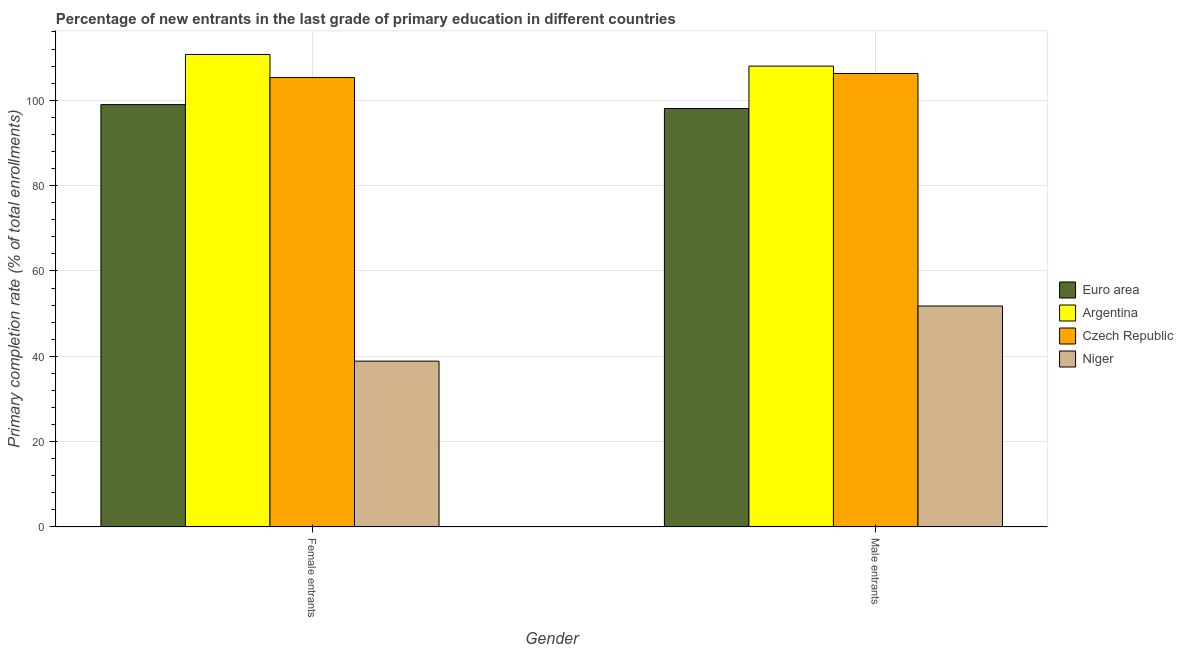How many different coloured bars are there?
Your response must be concise. 4. How many groups of bars are there?
Make the answer very short. 2. Are the number of bars per tick equal to the number of legend labels?
Your response must be concise. Yes. Are the number of bars on each tick of the X-axis equal?
Your answer should be compact. Yes. How many bars are there on the 2nd tick from the left?
Your response must be concise. 4. What is the label of the 2nd group of bars from the left?
Your answer should be compact. Male entrants. What is the primary completion rate of male entrants in Argentina?
Keep it short and to the point. 107.99. Across all countries, what is the maximum primary completion rate of female entrants?
Offer a very short reply. 110.73. Across all countries, what is the minimum primary completion rate of female entrants?
Offer a very short reply. 38.86. In which country was the primary completion rate of male entrants maximum?
Provide a succinct answer. Argentina. In which country was the primary completion rate of male entrants minimum?
Give a very brief answer. Niger. What is the total primary completion rate of male entrants in the graph?
Provide a succinct answer. 364.1. What is the difference between the primary completion rate of male entrants in Argentina and that in Czech Republic?
Offer a terse response. 1.73. What is the difference between the primary completion rate of male entrants in Czech Republic and the primary completion rate of female entrants in Euro area?
Give a very brief answer. 7.29. What is the average primary completion rate of female entrants per country?
Offer a very short reply. 88.47. What is the difference between the primary completion rate of female entrants and primary completion rate of male entrants in Czech Republic?
Make the answer very short. -0.95. In how many countries, is the primary completion rate of female entrants greater than 76 %?
Offer a very short reply. 3. What is the ratio of the primary completion rate of male entrants in Czech Republic to that in Euro area?
Give a very brief answer. 1.08. Is the primary completion rate of male entrants in Euro area less than that in Argentina?
Offer a very short reply. Yes. What does the 2nd bar from the left in Male entrants represents?
Offer a terse response. Argentina. What does the 2nd bar from the right in Female entrants represents?
Your answer should be compact. Czech Republic. How many bars are there?
Give a very brief answer. 8. Are all the bars in the graph horizontal?
Offer a terse response. No. How many countries are there in the graph?
Offer a terse response. 4. What is the difference between two consecutive major ticks on the Y-axis?
Provide a succinct answer. 20. Does the graph contain any zero values?
Your response must be concise. No. Where does the legend appear in the graph?
Provide a succinct answer. Center right. How are the legend labels stacked?
Offer a very short reply. Vertical. What is the title of the graph?
Make the answer very short. Percentage of new entrants in the last grade of primary education in different countries. Does "Middle income" appear as one of the legend labels in the graph?
Provide a short and direct response. No. What is the label or title of the Y-axis?
Ensure brevity in your answer.  Primary completion rate (% of total enrollments). What is the Primary completion rate (% of total enrollments) in Euro area in Female entrants?
Your response must be concise. 98.97. What is the Primary completion rate (% of total enrollments) in Argentina in Female entrants?
Offer a terse response. 110.73. What is the Primary completion rate (% of total enrollments) of Czech Republic in Female entrants?
Offer a terse response. 105.32. What is the Primary completion rate (% of total enrollments) of Niger in Female entrants?
Offer a very short reply. 38.86. What is the Primary completion rate (% of total enrollments) of Euro area in Male entrants?
Keep it short and to the point. 98.06. What is the Primary completion rate (% of total enrollments) in Argentina in Male entrants?
Your response must be concise. 107.99. What is the Primary completion rate (% of total enrollments) of Czech Republic in Male entrants?
Your response must be concise. 106.26. What is the Primary completion rate (% of total enrollments) in Niger in Male entrants?
Your answer should be compact. 51.78. Across all Gender, what is the maximum Primary completion rate (% of total enrollments) of Euro area?
Make the answer very short. 98.97. Across all Gender, what is the maximum Primary completion rate (% of total enrollments) of Argentina?
Ensure brevity in your answer.  110.73. Across all Gender, what is the maximum Primary completion rate (% of total enrollments) in Czech Republic?
Keep it short and to the point. 106.26. Across all Gender, what is the maximum Primary completion rate (% of total enrollments) in Niger?
Provide a short and direct response. 51.78. Across all Gender, what is the minimum Primary completion rate (% of total enrollments) in Euro area?
Your answer should be very brief. 98.06. Across all Gender, what is the minimum Primary completion rate (% of total enrollments) in Argentina?
Provide a short and direct response. 107.99. Across all Gender, what is the minimum Primary completion rate (% of total enrollments) of Czech Republic?
Ensure brevity in your answer.  105.32. Across all Gender, what is the minimum Primary completion rate (% of total enrollments) in Niger?
Keep it short and to the point. 38.86. What is the total Primary completion rate (% of total enrollments) of Euro area in the graph?
Offer a terse response. 197.04. What is the total Primary completion rate (% of total enrollments) in Argentina in the graph?
Ensure brevity in your answer.  218.72. What is the total Primary completion rate (% of total enrollments) in Czech Republic in the graph?
Your response must be concise. 211.58. What is the total Primary completion rate (% of total enrollments) of Niger in the graph?
Your answer should be compact. 90.64. What is the difference between the Primary completion rate (% of total enrollments) in Euro area in Female entrants and that in Male entrants?
Offer a very short reply. 0.91. What is the difference between the Primary completion rate (% of total enrollments) of Argentina in Female entrants and that in Male entrants?
Your answer should be very brief. 2.73. What is the difference between the Primary completion rate (% of total enrollments) of Czech Republic in Female entrants and that in Male entrants?
Your answer should be very brief. -0.95. What is the difference between the Primary completion rate (% of total enrollments) of Niger in Female entrants and that in Male entrants?
Keep it short and to the point. -12.92. What is the difference between the Primary completion rate (% of total enrollments) in Euro area in Female entrants and the Primary completion rate (% of total enrollments) in Argentina in Male entrants?
Your response must be concise. -9.02. What is the difference between the Primary completion rate (% of total enrollments) in Euro area in Female entrants and the Primary completion rate (% of total enrollments) in Czech Republic in Male entrants?
Provide a succinct answer. -7.29. What is the difference between the Primary completion rate (% of total enrollments) in Euro area in Female entrants and the Primary completion rate (% of total enrollments) in Niger in Male entrants?
Offer a terse response. 47.2. What is the difference between the Primary completion rate (% of total enrollments) in Argentina in Female entrants and the Primary completion rate (% of total enrollments) in Czech Republic in Male entrants?
Ensure brevity in your answer.  4.47. What is the difference between the Primary completion rate (% of total enrollments) of Argentina in Female entrants and the Primary completion rate (% of total enrollments) of Niger in Male entrants?
Your answer should be very brief. 58.95. What is the difference between the Primary completion rate (% of total enrollments) of Czech Republic in Female entrants and the Primary completion rate (% of total enrollments) of Niger in Male entrants?
Ensure brevity in your answer.  53.54. What is the average Primary completion rate (% of total enrollments) in Euro area per Gender?
Offer a very short reply. 98.52. What is the average Primary completion rate (% of total enrollments) of Argentina per Gender?
Keep it short and to the point. 109.36. What is the average Primary completion rate (% of total enrollments) in Czech Republic per Gender?
Offer a terse response. 105.79. What is the average Primary completion rate (% of total enrollments) of Niger per Gender?
Offer a terse response. 45.32. What is the difference between the Primary completion rate (% of total enrollments) in Euro area and Primary completion rate (% of total enrollments) in Argentina in Female entrants?
Keep it short and to the point. -11.75. What is the difference between the Primary completion rate (% of total enrollments) of Euro area and Primary completion rate (% of total enrollments) of Czech Republic in Female entrants?
Ensure brevity in your answer.  -6.34. What is the difference between the Primary completion rate (% of total enrollments) in Euro area and Primary completion rate (% of total enrollments) in Niger in Female entrants?
Ensure brevity in your answer.  60.11. What is the difference between the Primary completion rate (% of total enrollments) in Argentina and Primary completion rate (% of total enrollments) in Czech Republic in Female entrants?
Make the answer very short. 5.41. What is the difference between the Primary completion rate (% of total enrollments) in Argentina and Primary completion rate (% of total enrollments) in Niger in Female entrants?
Offer a very short reply. 71.87. What is the difference between the Primary completion rate (% of total enrollments) of Czech Republic and Primary completion rate (% of total enrollments) of Niger in Female entrants?
Offer a very short reply. 66.45. What is the difference between the Primary completion rate (% of total enrollments) of Euro area and Primary completion rate (% of total enrollments) of Argentina in Male entrants?
Make the answer very short. -9.93. What is the difference between the Primary completion rate (% of total enrollments) in Euro area and Primary completion rate (% of total enrollments) in Czech Republic in Male entrants?
Your response must be concise. -8.2. What is the difference between the Primary completion rate (% of total enrollments) of Euro area and Primary completion rate (% of total enrollments) of Niger in Male entrants?
Provide a succinct answer. 46.28. What is the difference between the Primary completion rate (% of total enrollments) in Argentina and Primary completion rate (% of total enrollments) in Czech Republic in Male entrants?
Offer a very short reply. 1.73. What is the difference between the Primary completion rate (% of total enrollments) of Argentina and Primary completion rate (% of total enrollments) of Niger in Male entrants?
Make the answer very short. 56.22. What is the difference between the Primary completion rate (% of total enrollments) in Czech Republic and Primary completion rate (% of total enrollments) in Niger in Male entrants?
Your answer should be very brief. 54.48. What is the ratio of the Primary completion rate (% of total enrollments) of Euro area in Female entrants to that in Male entrants?
Your answer should be compact. 1.01. What is the ratio of the Primary completion rate (% of total enrollments) of Argentina in Female entrants to that in Male entrants?
Offer a very short reply. 1.03. What is the ratio of the Primary completion rate (% of total enrollments) of Niger in Female entrants to that in Male entrants?
Provide a short and direct response. 0.75. What is the difference between the highest and the second highest Primary completion rate (% of total enrollments) of Euro area?
Your response must be concise. 0.91. What is the difference between the highest and the second highest Primary completion rate (% of total enrollments) in Argentina?
Give a very brief answer. 2.73. What is the difference between the highest and the second highest Primary completion rate (% of total enrollments) in Czech Republic?
Keep it short and to the point. 0.95. What is the difference between the highest and the second highest Primary completion rate (% of total enrollments) of Niger?
Offer a terse response. 12.92. What is the difference between the highest and the lowest Primary completion rate (% of total enrollments) in Euro area?
Make the answer very short. 0.91. What is the difference between the highest and the lowest Primary completion rate (% of total enrollments) of Argentina?
Your answer should be compact. 2.73. What is the difference between the highest and the lowest Primary completion rate (% of total enrollments) in Czech Republic?
Provide a succinct answer. 0.95. What is the difference between the highest and the lowest Primary completion rate (% of total enrollments) of Niger?
Keep it short and to the point. 12.92. 